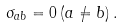<formula> <loc_0><loc_0><loc_500><loc_500>\sigma _ { a b } = 0 \, ( a \neq b ) \, .</formula> 